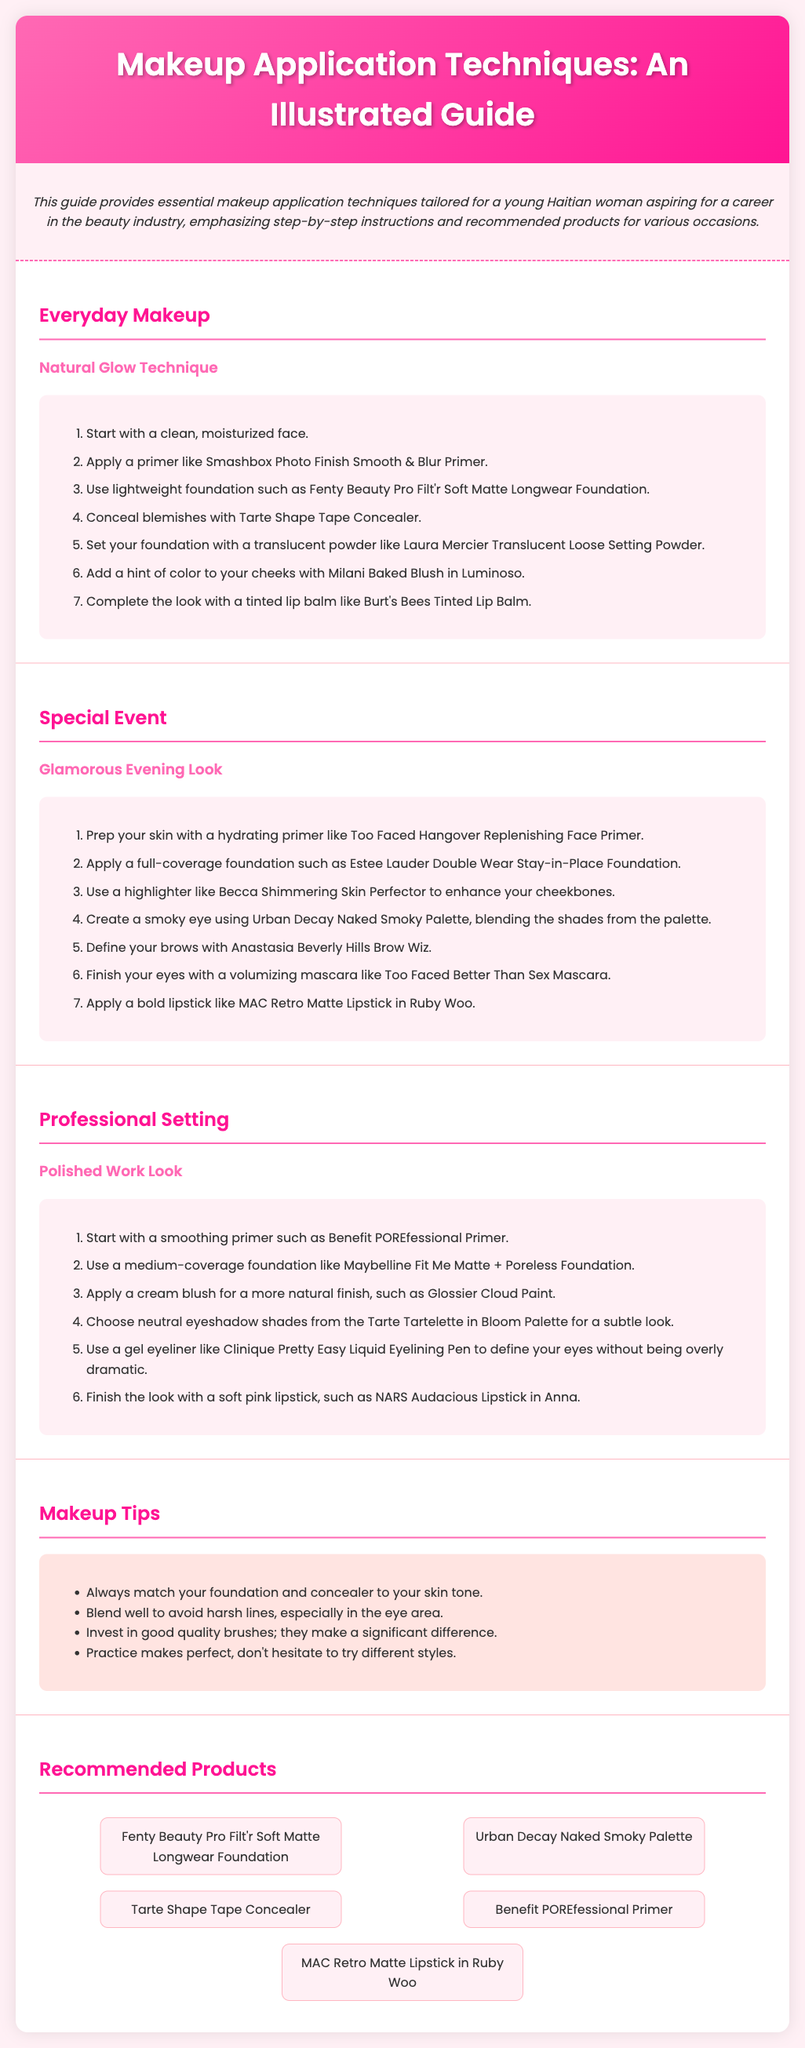what is the title of the guide? The title is stated prominently at the top of the document, referring specifically to makeup application techniques.
Answer: Makeup Application Techniques: An Illustrated Guide what is the first step in the Natural Glow Technique? The first step is provided in the list of steps for the Natural Glow Technique section.
Answer: Start with a clean, moisturized face which product is suggested for a smoky eye? The document lists a specific product to be used when creating a smoky eye in the Glamorous Evening Look.
Answer: Urban Decay Naked Smoky Palette how many sections are there in the guide? The document contains several sections, and the total is counted from the section headings.
Answer: Five what type of foundation is recommended for Professional Setting? The document specifies the type of foundation suitable for the Professional Setting section.
Answer: Medium-coverage foundation what common tip is stated for applying makeup? A general advice is given in the Makeup Tips section that applies to makeup application.
Answer: Blend well to avoid harsh lines which lipstick is recommended for a bold look? The recommended bold lipstick is mentioned in the steps for the Glamorous Evening Look.
Answer: MAC Retro Matte Lipstick in Ruby Woo what is the function of a primer in makeup application? The guide suggests that a primer serves a specific purpose before applying other makeup products.
Answer: Preps the skin which product is listed for setting foundation? The recommended product for setting foundation is mentioned in the Everyday Makeup section.
Answer: Laura Mercier Translucent Loose Setting Powder 